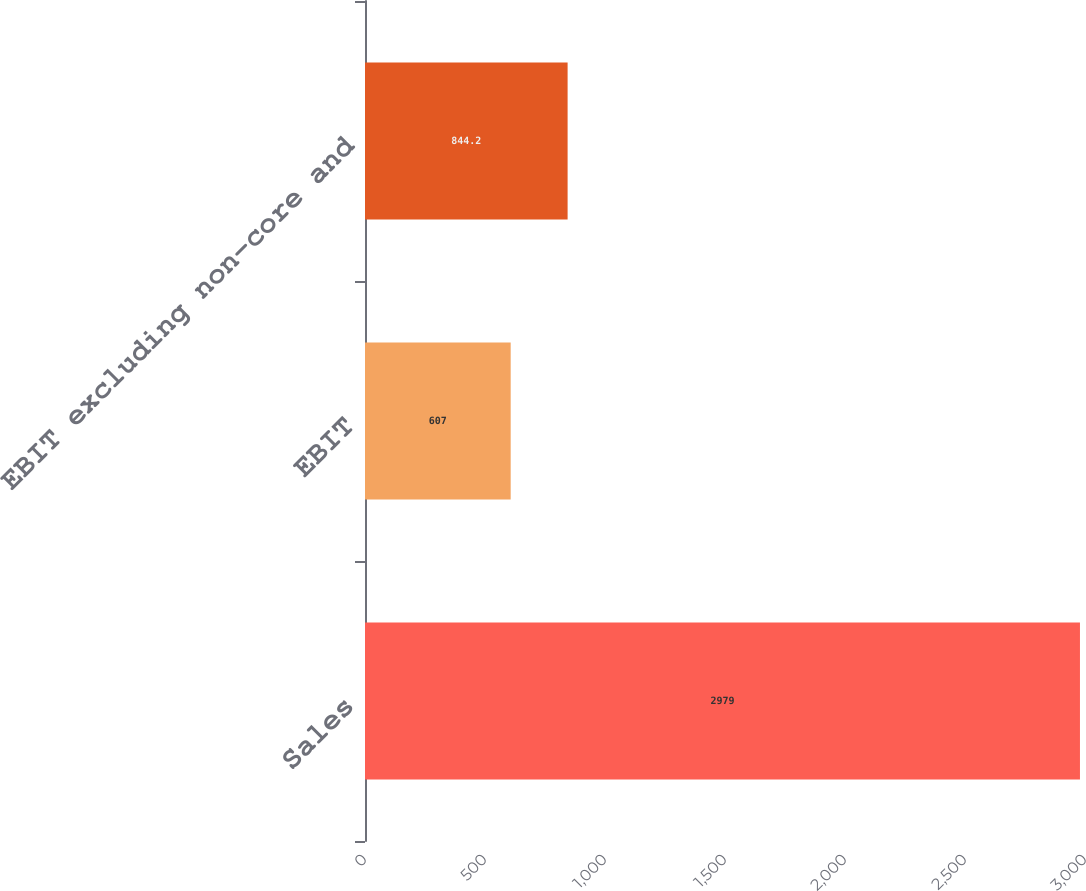<chart> <loc_0><loc_0><loc_500><loc_500><bar_chart><fcel>Sales<fcel>EBIT<fcel>EBIT excluding non-core and<nl><fcel>2979<fcel>607<fcel>844.2<nl></chart> 